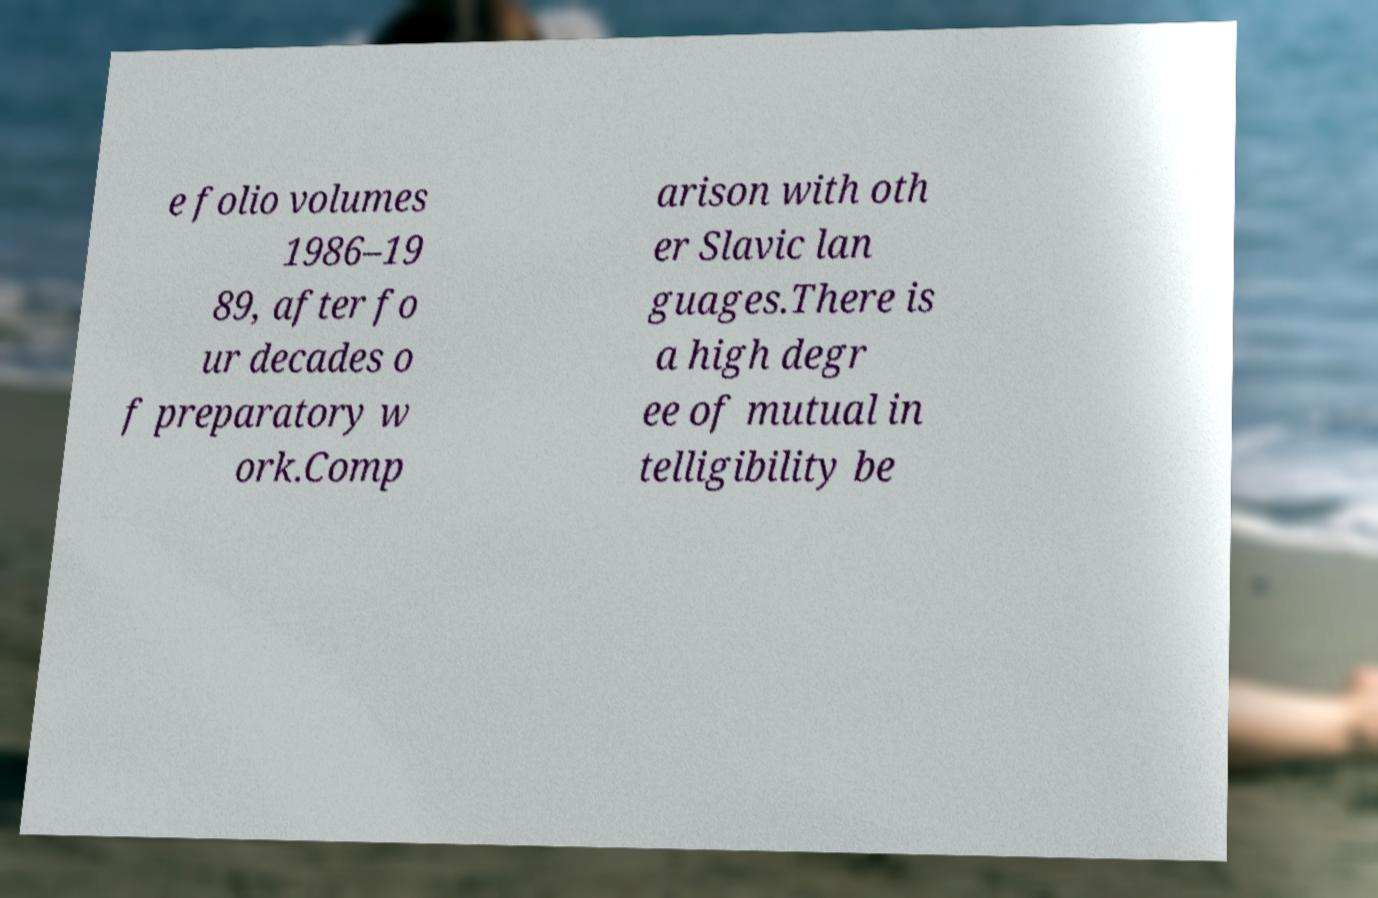I need the written content from this picture converted into text. Can you do that? e folio volumes 1986–19 89, after fo ur decades o f preparatory w ork.Comp arison with oth er Slavic lan guages.There is a high degr ee of mutual in telligibility be 